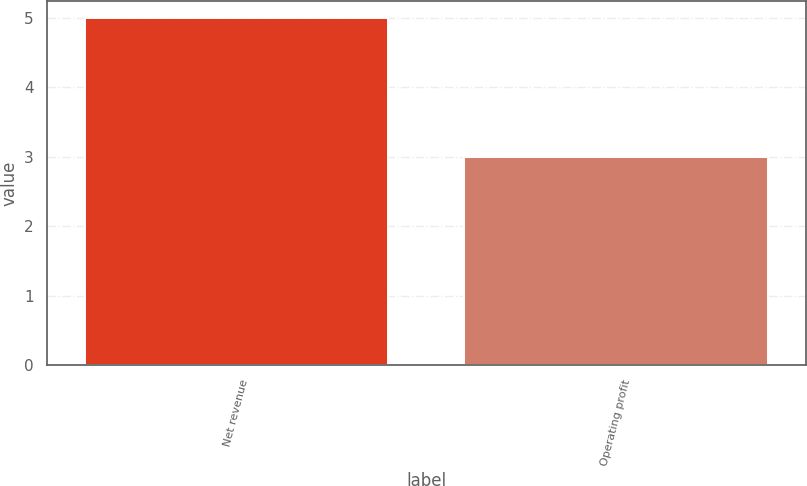<chart> <loc_0><loc_0><loc_500><loc_500><bar_chart><fcel>Net revenue<fcel>Operating profit<nl><fcel>5<fcel>3<nl></chart> 